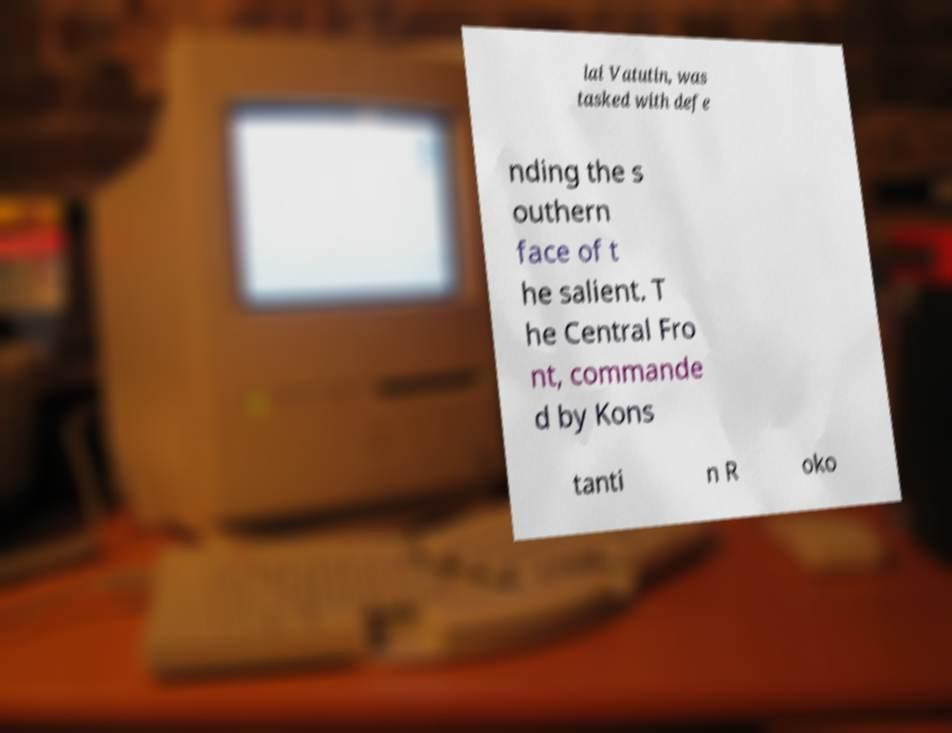For documentation purposes, I need the text within this image transcribed. Could you provide that? lai Vatutin, was tasked with defe nding the s outhern face of t he salient. T he Central Fro nt, commande d by Kons tanti n R oko 